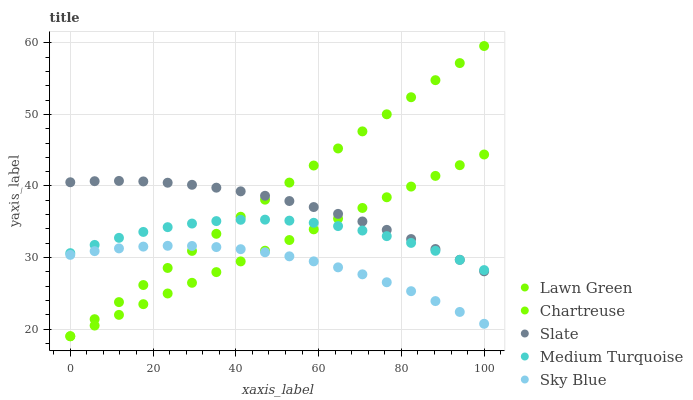Does Sky Blue have the minimum area under the curve?
Answer yes or no. Yes. Does Lawn Green have the maximum area under the curve?
Answer yes or no. Yes. Does Chartreuse have the minimum area under the curve?
Answer yes or no. No. Does Chartreuse have the maximum area under the curve?
Answer yes or no. No. Is Chartreuse the smoothest?
Answer yes or no. Yes. Is Medium Turquoise the roughest?
Answer yes or no. Yes. Is Slate the smoothest?
Answer yes or no. No. Is Slate the roughest?
Answer yes or no. No. Does Lawn Green have the lowest value?
Answer yes or no. Yes. Does Slate have the lowest value?
Answer yes or no. No. Does Lawn Green have the highest value?
Answer yes or no. Yes. Does Chartreuse have the highest value?
Answer yes or no. No. Is Sky Blue less than Slate?
Answer yes or no. Yes. Is Medium Turquoise greater than Sky Blue?
Answer yes or no. Yes. Does Lawn Green intersect Sky Blue?
Answer yes or no. Yes. Is Lawn Green less than Sky Blue?
Answer yes or no. No. Is Lawn Green greater than Sky Blue?
Answer yes or no. No. Does Sky Blue intersect Slate?
Answer yes or no. No. 